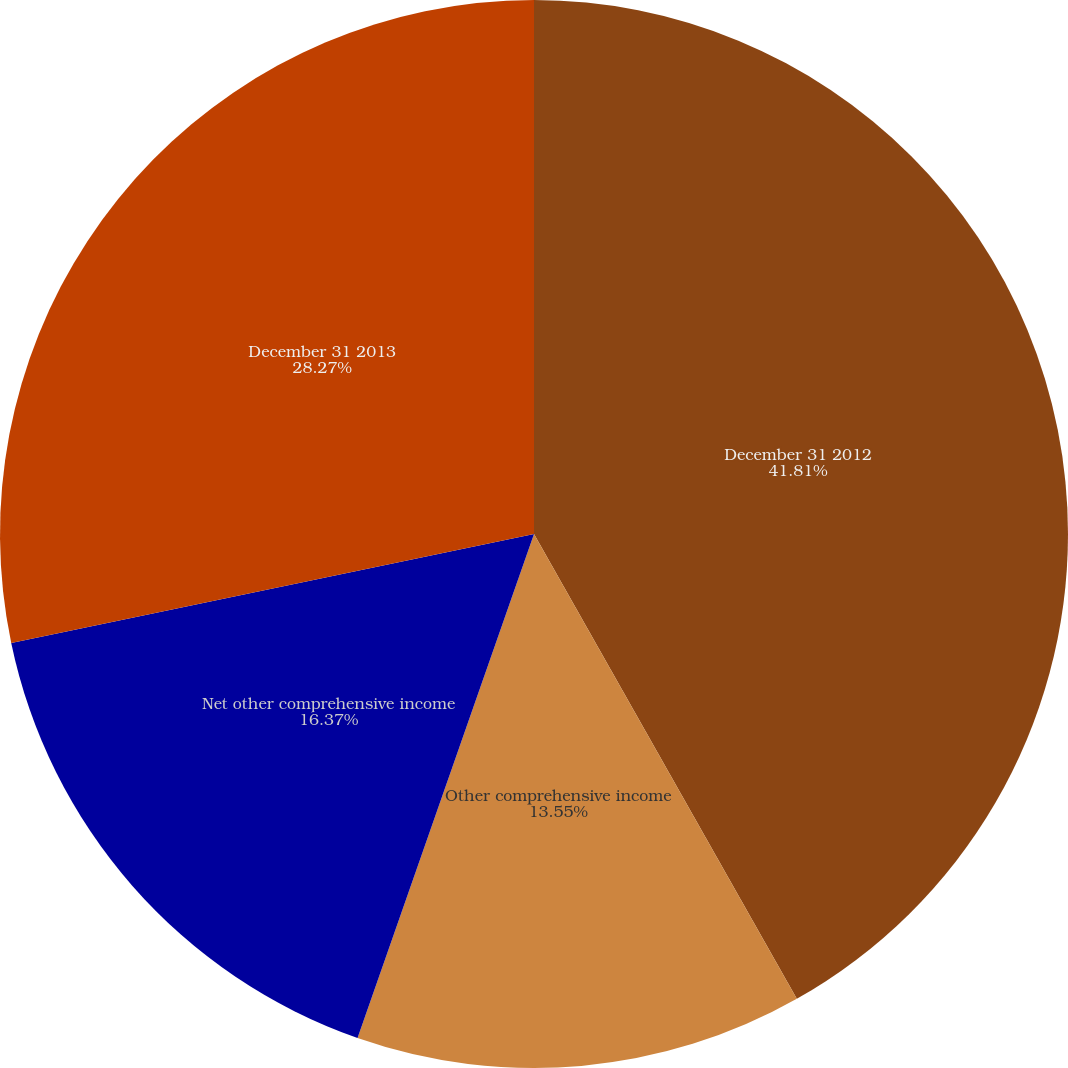Convert chart to OTSL. <chart><loc_0><loc_0><loc_500><loc_500><pie_chart><fcel>December 31 2012<fcel>Other comprehensive income<fcel>Net other comprehensive income<fcel>December 31 2013<nl><fcel>41.81%<fcel>13.55%<fcel>16.37%<fcel>28.27%<nl></chart> 